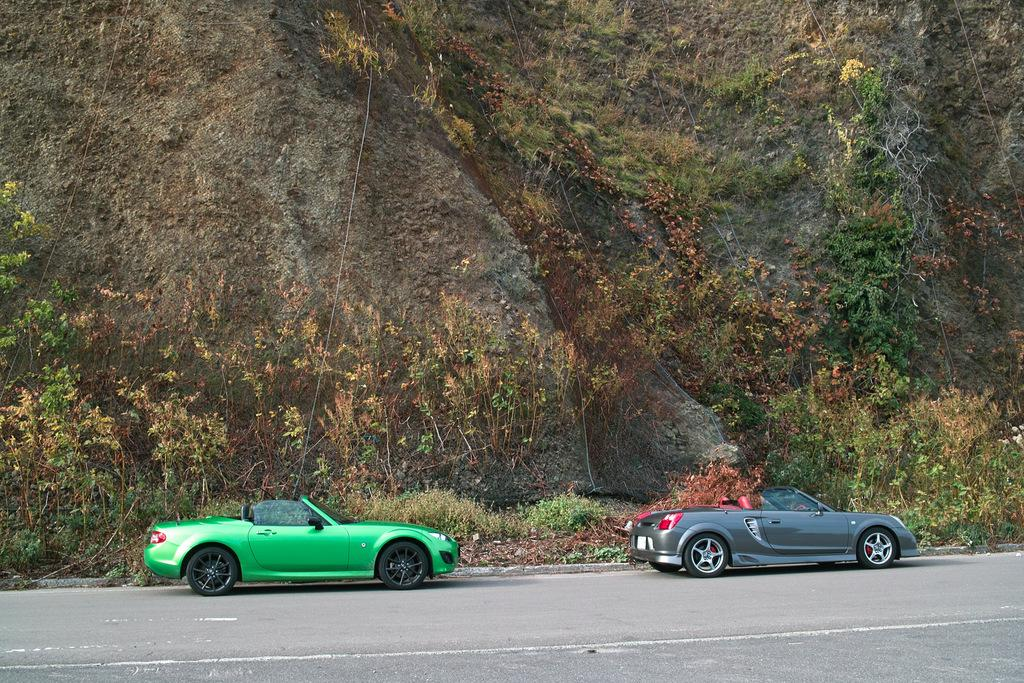How many cars are parked on the road in the image? There are two cars parked on the road in the image. What can be seen in the background of the image? There is a group of plants and a mountain visible in the background. What is the weight of the parent in the image? There is no parent present in the image, so it is not possible to determine their weight. 